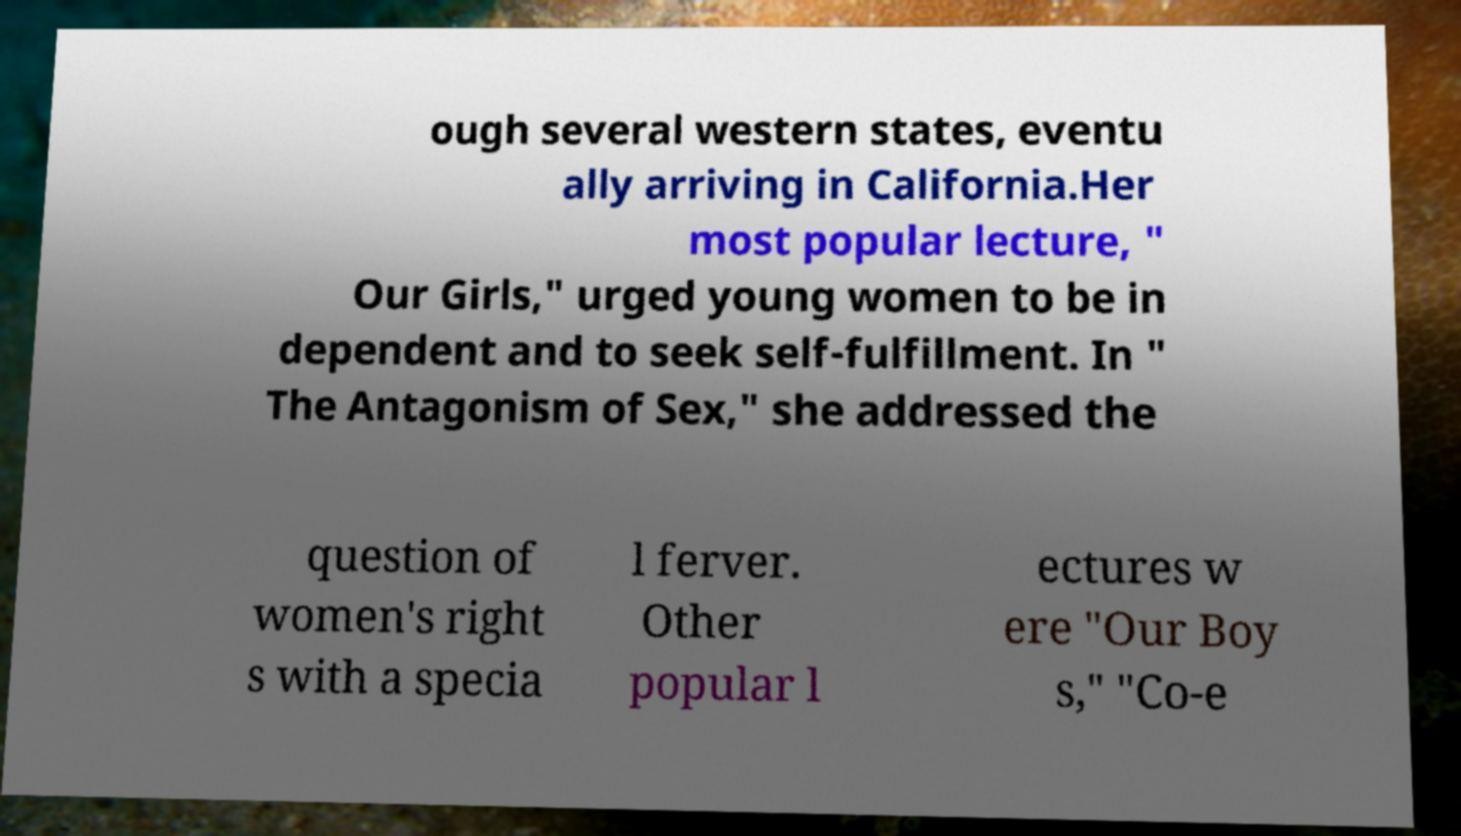For documentation purposes, I need the text within this image transcribed. Could you provide that? ough several western states, eventu ally arriving in California.Her most popular lecture, " Our Girls," urged young women to be in dependent and to seek self-fulfillment. In " The Antagonism of Sex," she addressed the question of women's right s with a specia l ferver. Other popular l ectures w ere "Our Boy s," "Co-e 